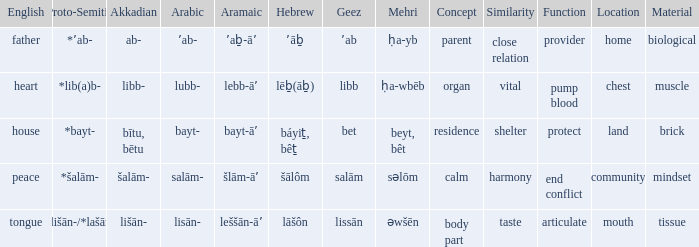If in arabic it is salām-, what is it in proto-semitic? *šalām-. 